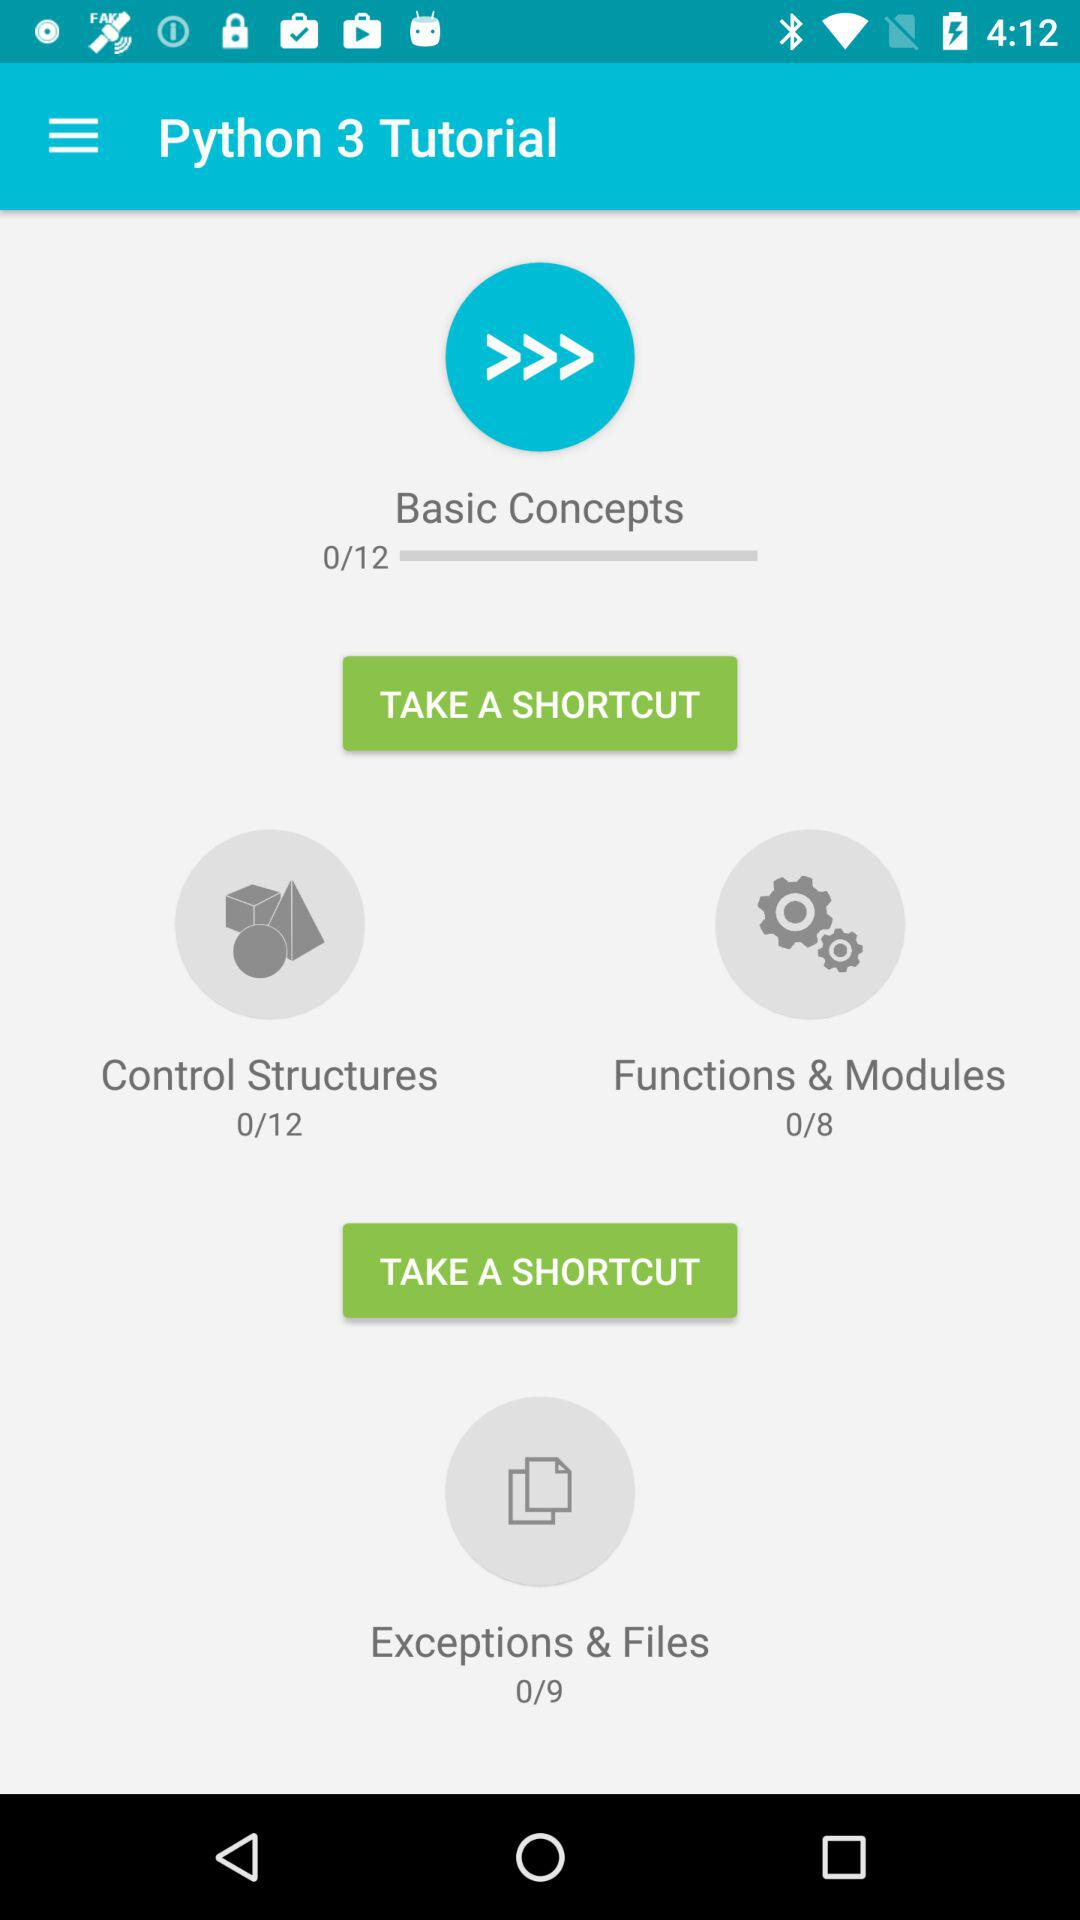How many slides are covered in "Control Structures"? In "Control Structures", there are 12 slides covered. 